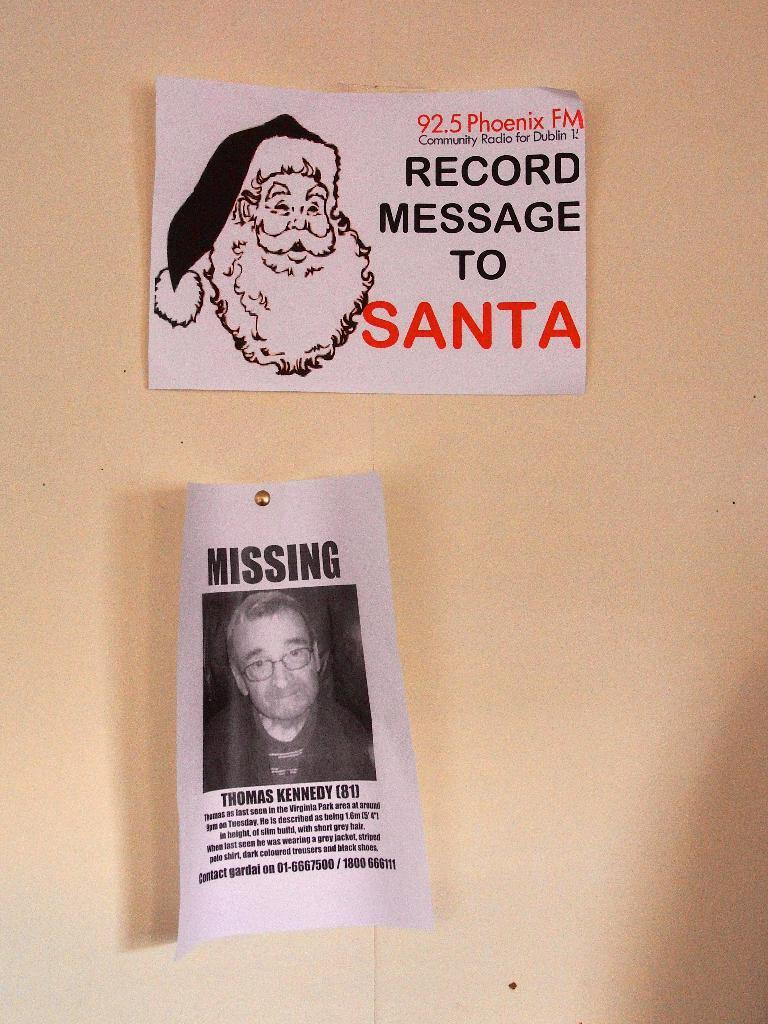How many posters are visible in the image? There are two posters in the image. What is the background color of the posters? The posters are on a cream surface. Where are the posters located in relation to the image? The posters are in the foreground of the image. What type of government is depicted on the posters in the image? There is no indication of any government on the posters in the image. Can you see a zebra on the posters in the image? There is no zebra present on the posters in the image. 